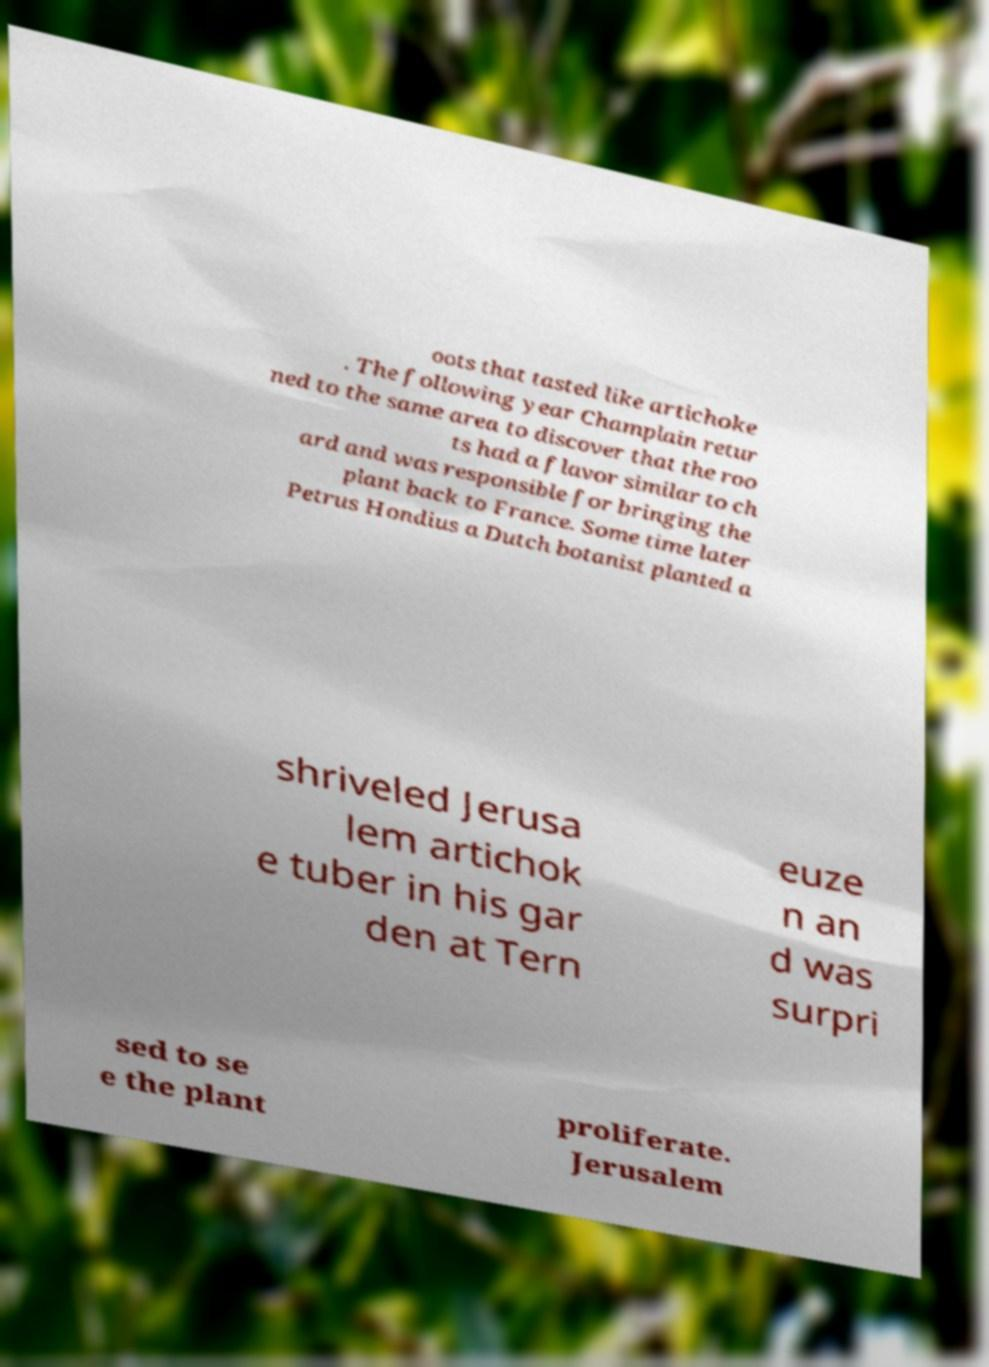Could you assist in decoding the text presented in this image and type it out clearly? oots that tasted like artichoke . The following year Champlain retur ned to the same area to discover that the roo ts had a flavor similar to ch ard and was responsible for bringing the plant back to France. Some time later Petrus Hondius a Dutch botanist planted a shriveled Jerusa lem artichok e tuber in his gar den at Tern euze n an d was surpri sed to se e the plant proliferate. Jerusalem 